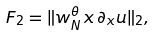Convert formula to latex. <formula><loc_0><loc_0><loc_500><loc_500>F _ { 2 } = \| w _ { N } ^ { \theta } \, x \, \partial _ { x } u \| _ { 2 } ,</formula> 